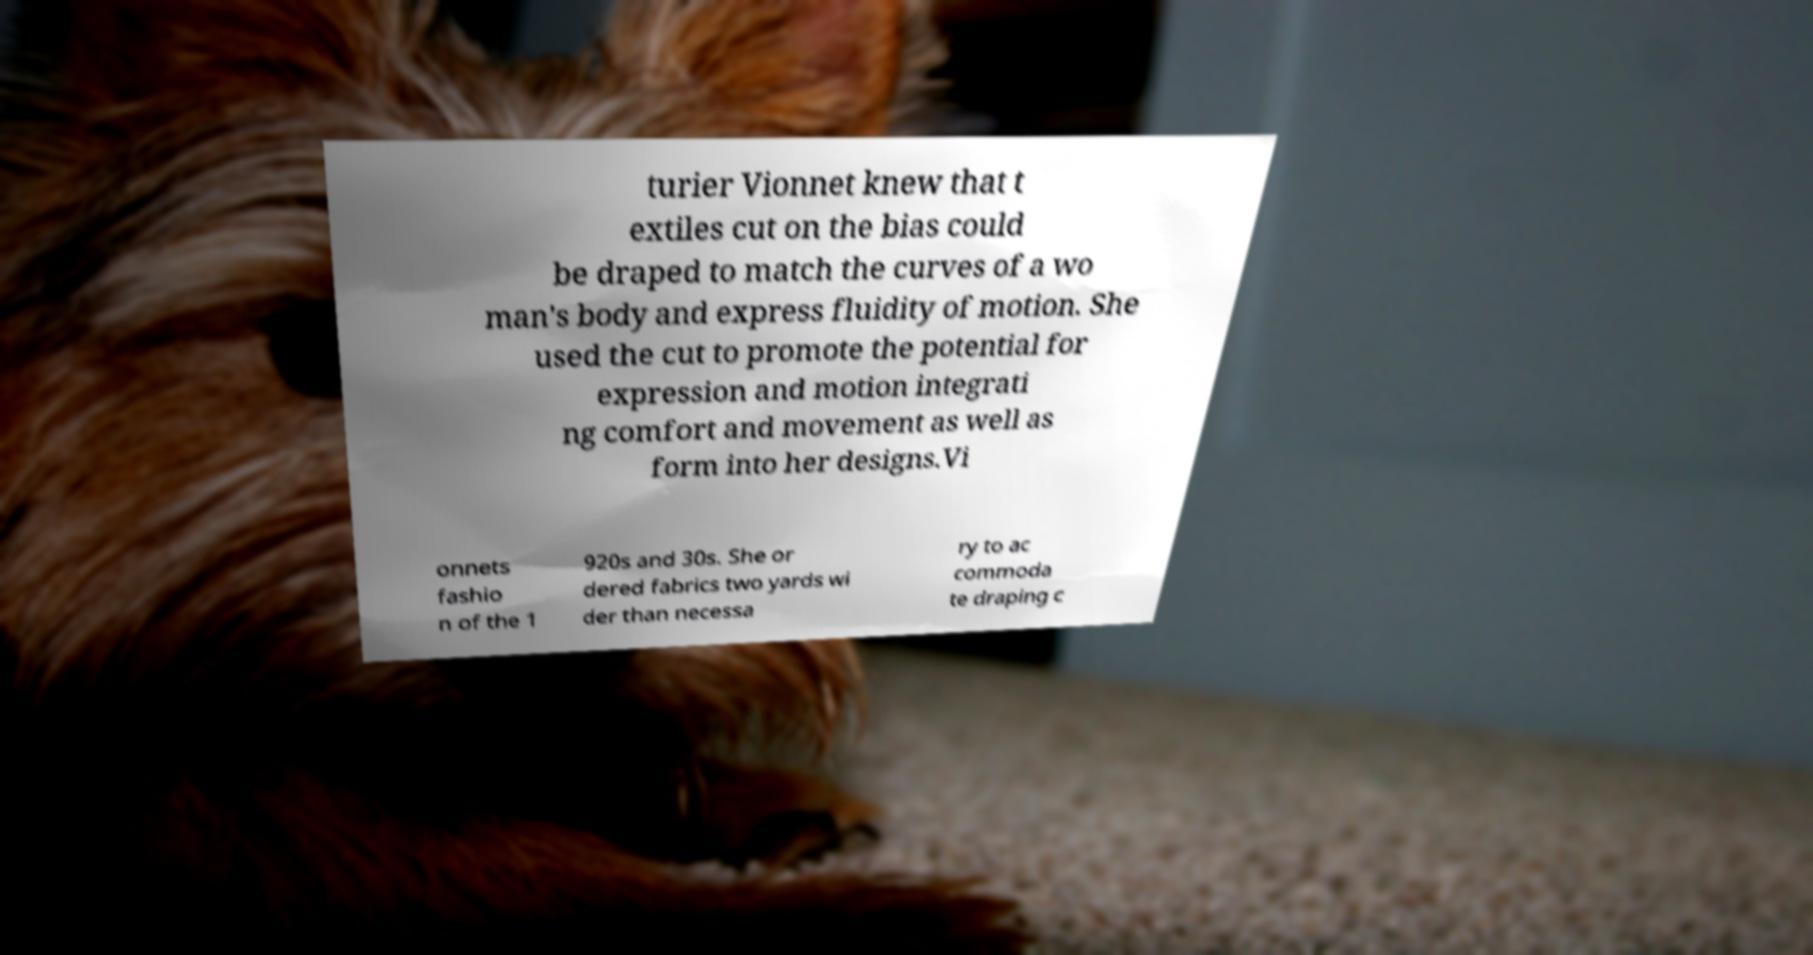For documentation purposes, I need the text within this image transcribed. Could you provide that? turier Vionnet knew that t extiles cut on the bias could be draped to match the curves of a wo man's body and express fluidity of motion. She used the cut to promote the potential for expression and motion integrati ng comfort and movement as well as form into her designs.Vi onnets fashio n of the 1 920s and 30s. She or dered fabrics two yards wi der than necessa ry to ac commoda te draping c 